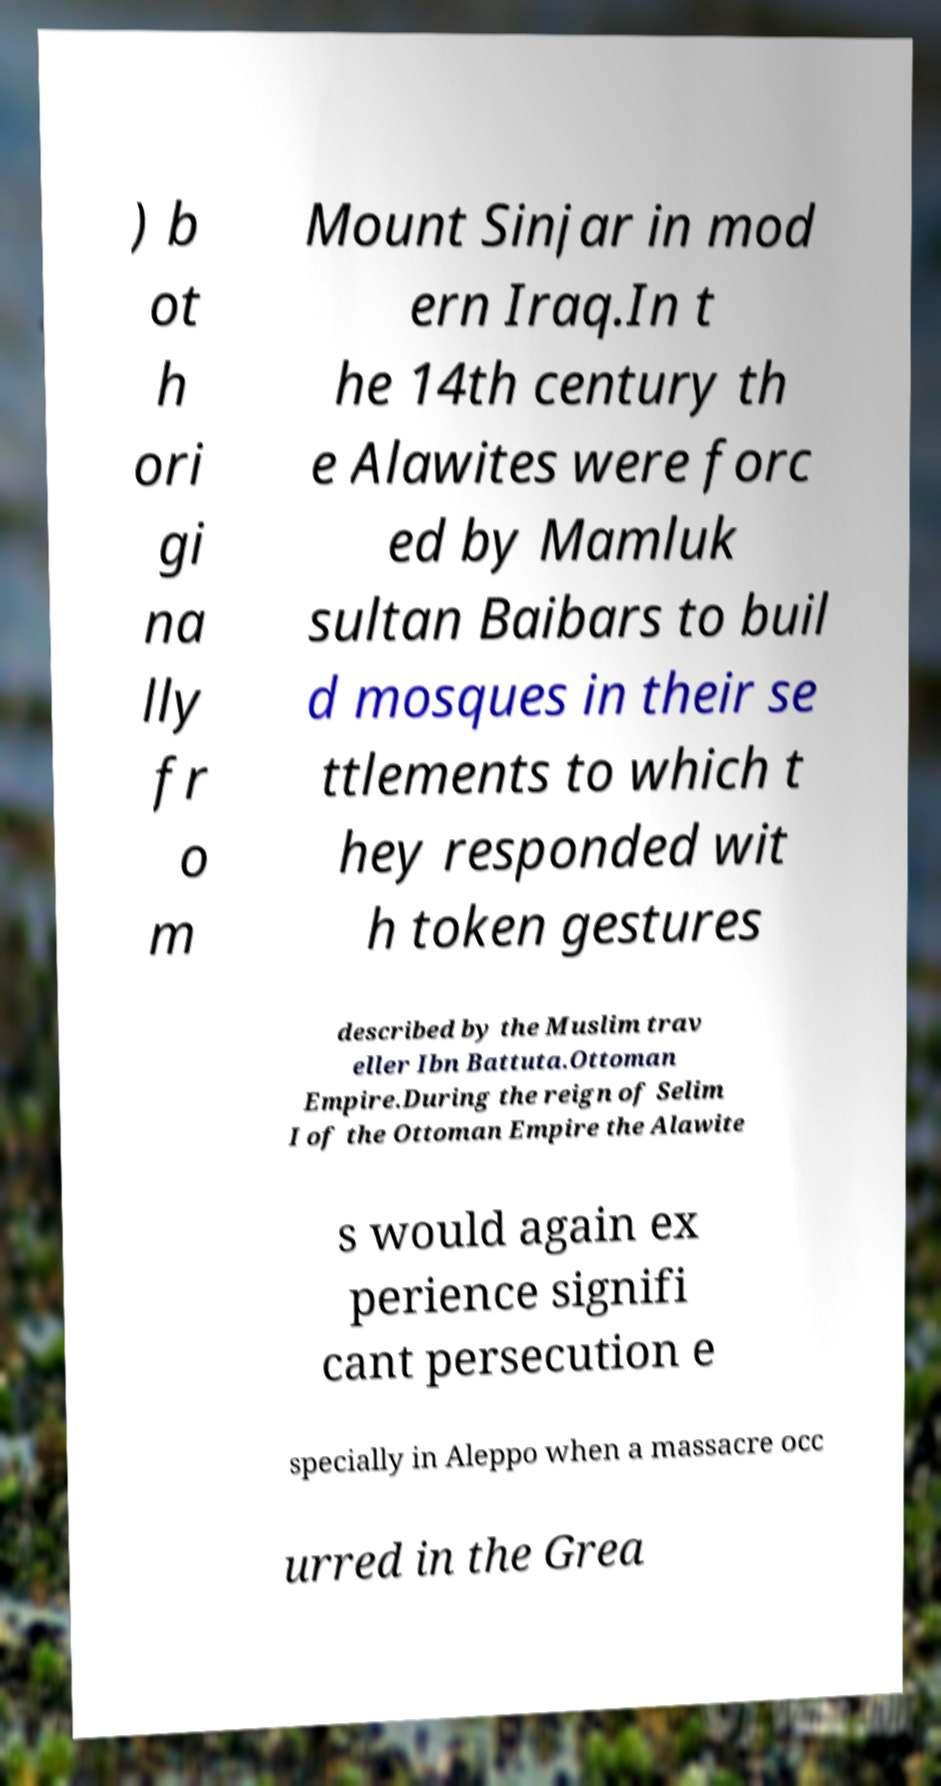Please read and relay the text visible in this image. What does it say? ) b ot h ori gi na lly fr o m Mount Sinjar in mod ern Iraq.In t he 14th century th e Alawites were forc ed by Mamluk sultan Baibars to buil d mosques in their se ttlements to which t hey responded wit h token gestures described by the Muslim trav eller Ibn Battuta.Ottoman Empire.During the reign of Selim I of the Ottoman Empire the Alawite s would again ex perience signifi cant persecution e specially in Aleppo when a massacre occ urred in the Grea 